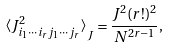<formula> <loc_0><loc_0><loc_500><loc_500>\left < J _ { i _ { 1 } \cdots i _ { r } j _ { 1 } \cdots j _ { r } } ^ { 2 } \right > _ { J } = \frac { J ^ { 2 } ( r ! ) ^ { 2 } } { N ^ { 2 r - 1 } } ,</formula> 